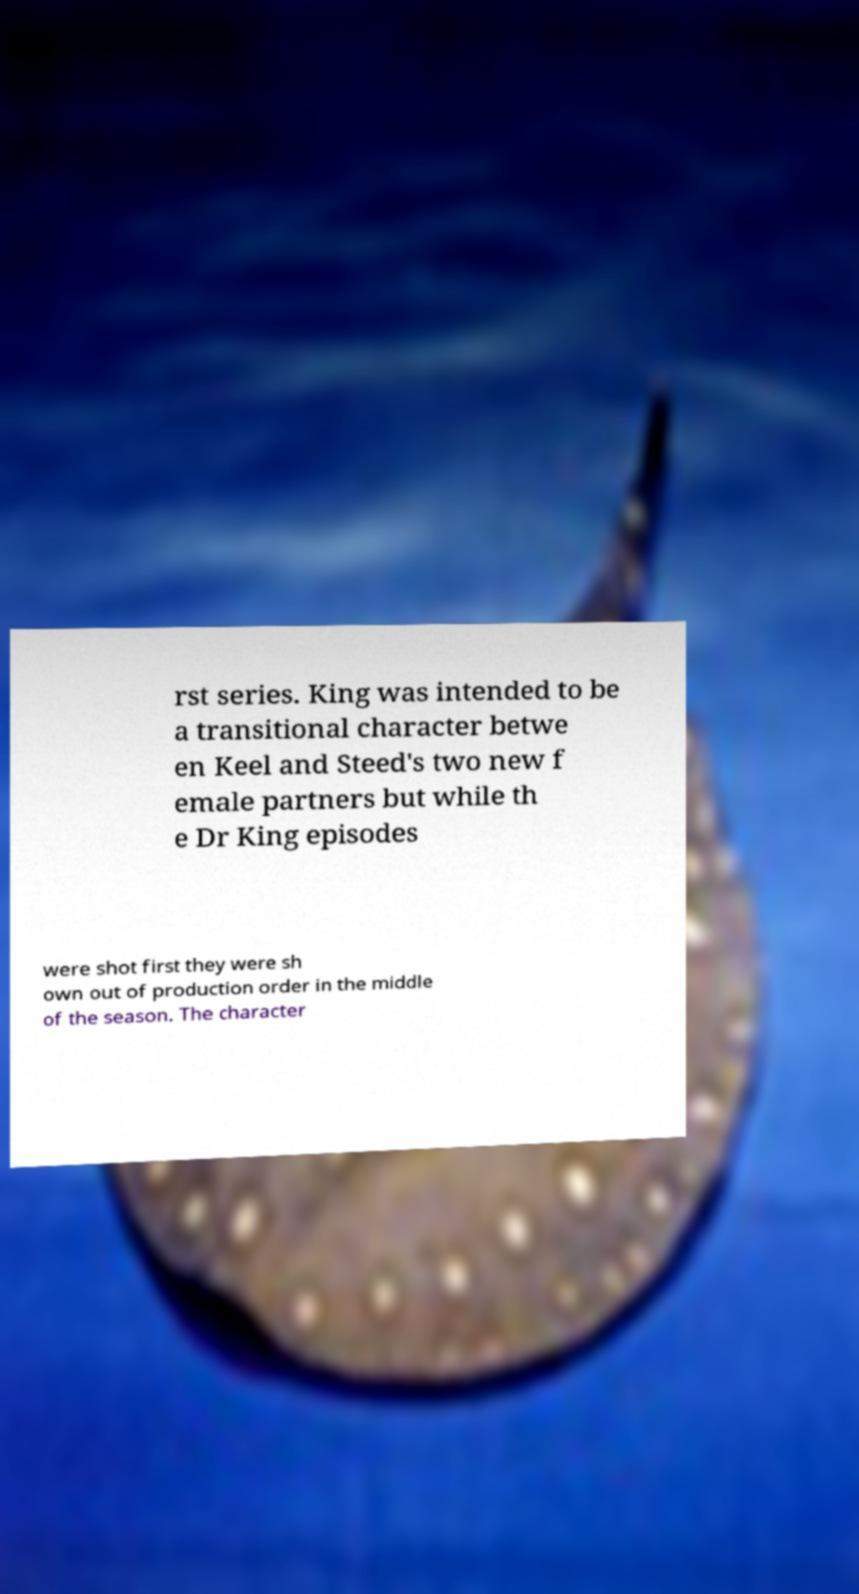For documentation purposes, I need the text within this image transcribed. Could you provide that? rst series. King was intended to be a transitional character betwe en Keel and Steed's two new f emale partners but while th e Dr King episodes were shot first they were sh own out of production order in the middle of the season. The character 